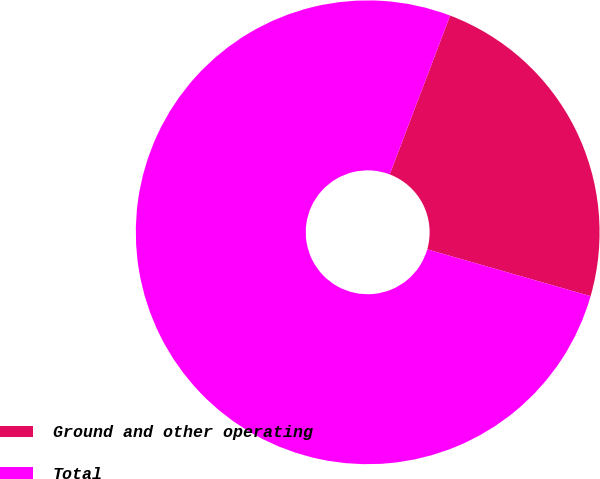<chart> <loc_0><loc_0><loc_500><loc_500><pie_chart><fcel>Ground and other operating<fcel>Total<nl><fcel>23.66%<fcel>76.34%<nl></chart> 